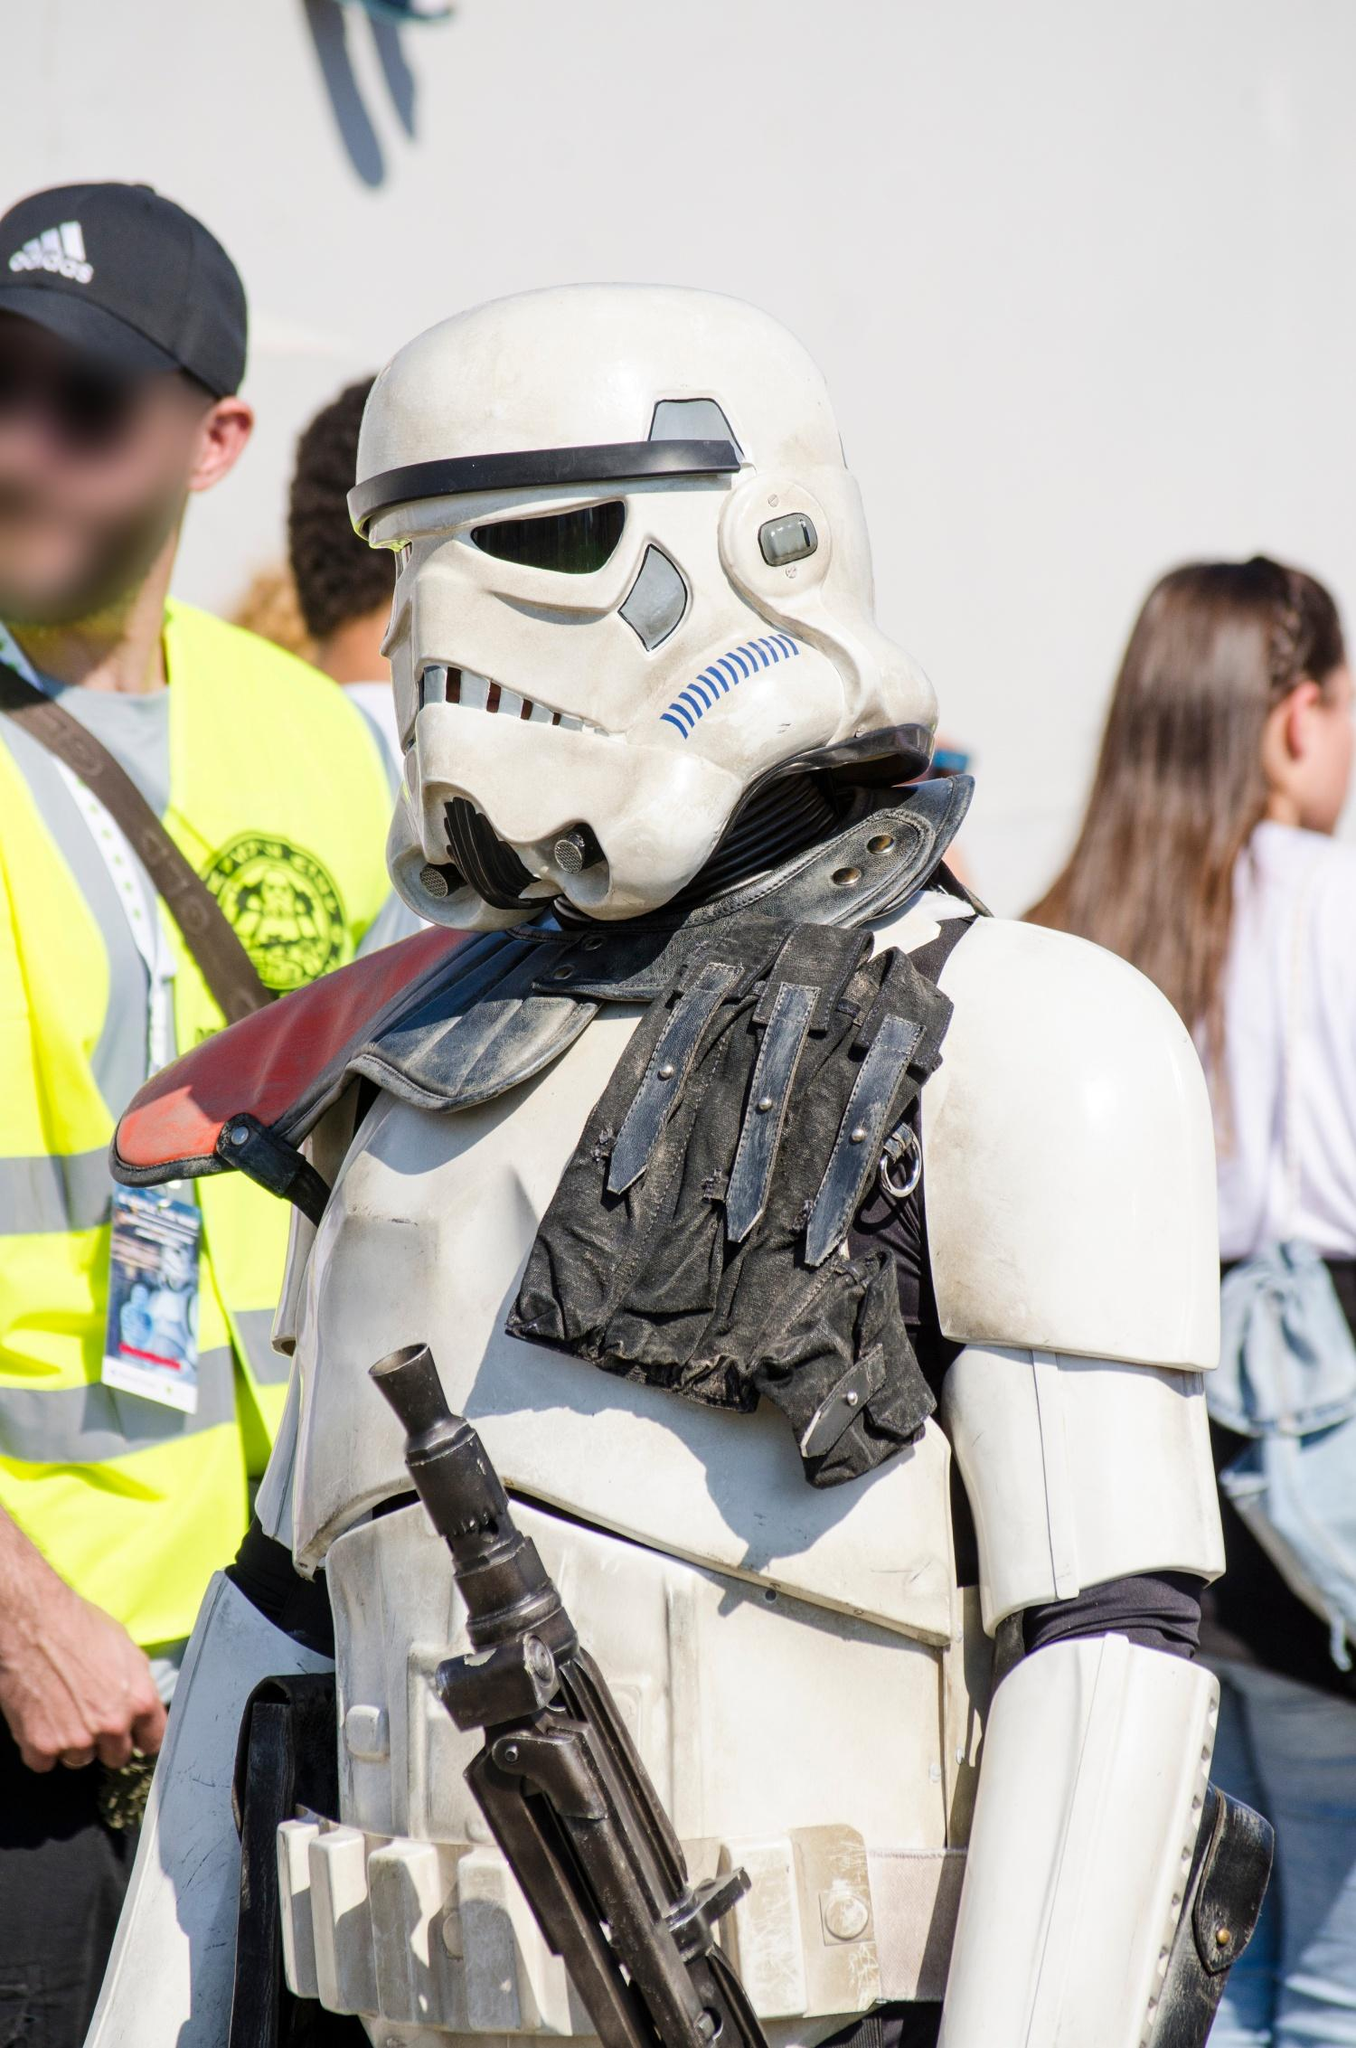What event do you think this image was taken at? Given the detailed costume and the presence of a security guard, it is likely that this image was taken at a fan convention, such as Comic-Con or a similar pop culture event where fans of sci-fi, comics, and movies gather to celebrate and showcase their costumes and memorabilia. 